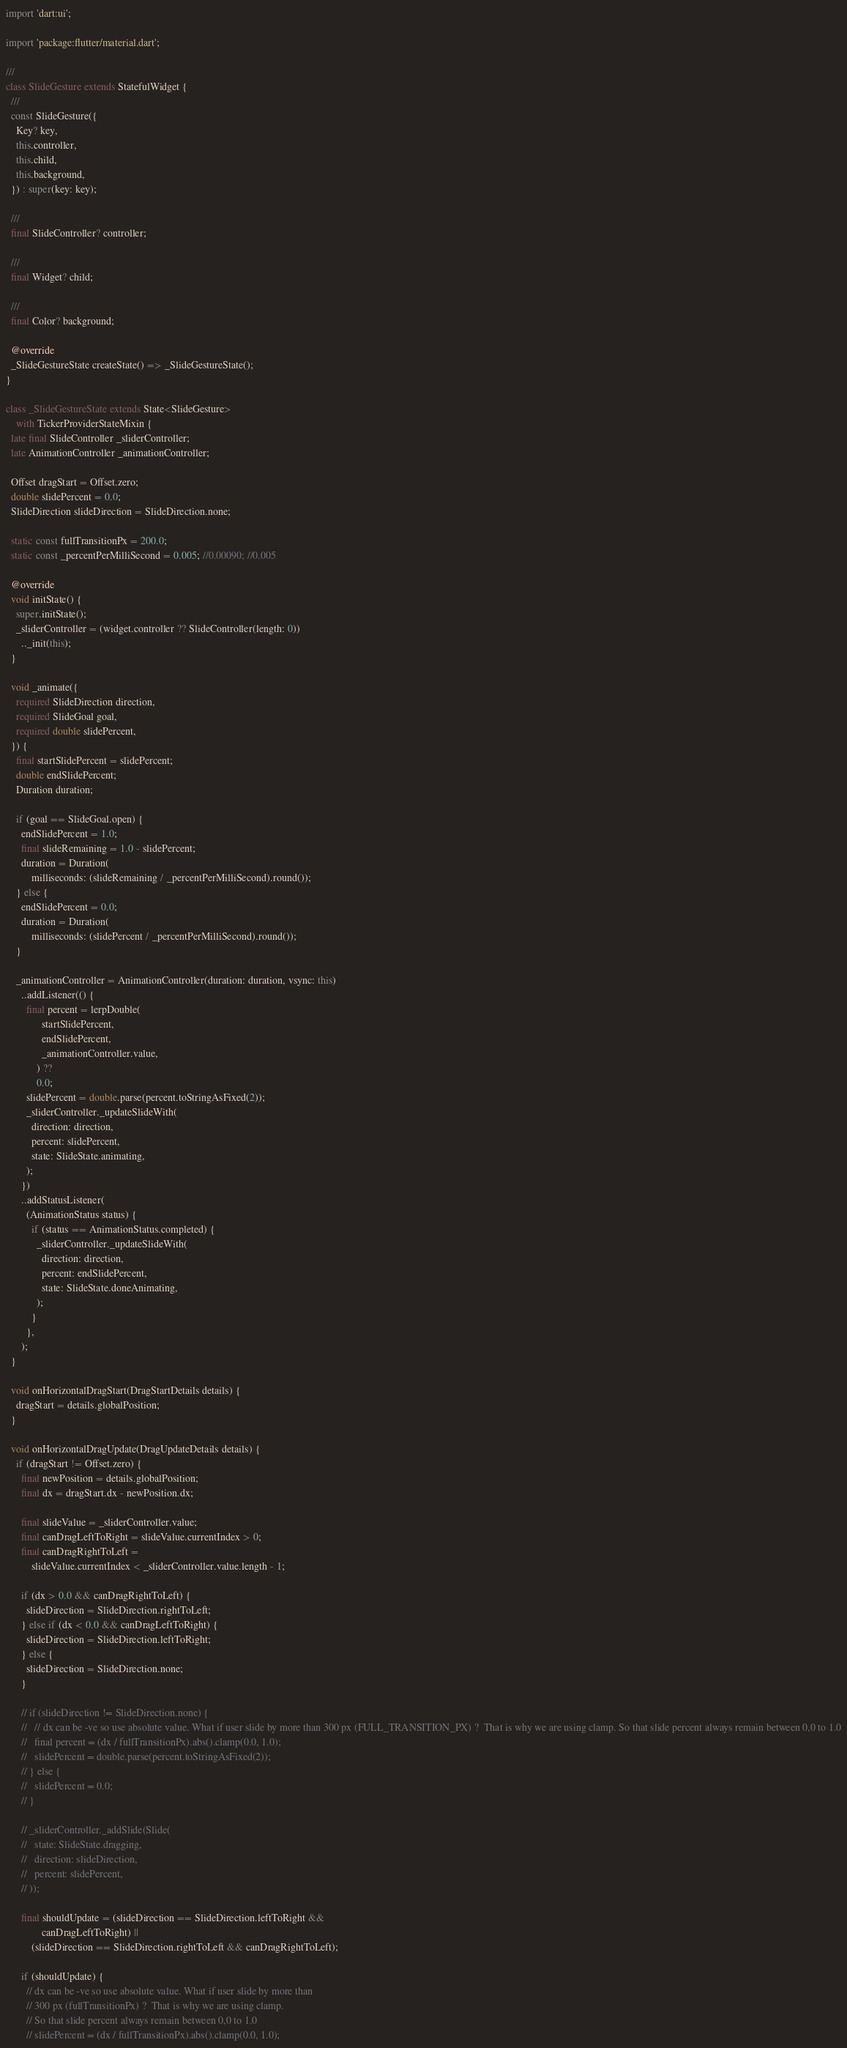Convert code to text. <code><loc_0><loc_0><loc_500><loc_500><_Dart_>import 'dart:ui';

import 'package:flutter/material.dart';

///
class SlideGesture extends StatefulWidget {
  ///
  const SlideGesture({
    Key? key,
    this.controller,
    this.child,
    this.background,
  }) : super(key: key);

  ///
  final SlideController? controller;

  ///
  final Widget? child;

  ///
  final Color? background;

  @override
  _SlideGestureState createState() => _SlideGestureState();
}

class _SlideGestureState extends State<SlideGesture>
    with TickerProviderStateMixin {
  late final SlideController _sliderController;
  late AnimationController _animationController;

  Offset dragStart = Offset.zero;
  double slidePercent = 0.0;
  SlideDirection slideDirection = SlideDirection.none;

  static const fullTransitionPx = 200.0;
  static const _percentPerMilliSecond = 0.005; //0.00090; //0.005

  @override
  void initState() {
    super.initState();
    _sliderController = (widget.controller ?? SlideController(length: 0))
      .._init(this);
  }

  void _animate({
    required SlideDirection direction,
    required SlideGoal goal,
    required double slidePercent,
  }) {
    final startSlidePercent = slidePercent;
    double endSlidePercent;
    Duration duration;

    if (goal == SlideGoal.open) {
      endSlidePercent = 1.0;
      final slideRemaining = 1.0 - slidePercent;
      duration = Duration(
          milliseconds: (slideRemaining / _percentPerMilliSecond).round());
    } else {
      endSlidePercent = 0.0;
      duration = Duration(
          milliseconds: (slidePercent / _percentPerMilliSecond).round());
    }

    _animationController = AnimationController(duration: duration, vsync: this)
      ..addListener(() {
        final percent = lerpDouble(
              startSlidePercent,
              endSlidePercent,
              _animationController.value,
            ) ??
            0.0;
        slidePercent = double.parse(percent.toStringAsFixed(2));
        _sliderController._updateSlideWith(
          direction: direction,
          percent: slidePercent,
          state: SlideState.animating,
        );
      })
      ..addStatusListener(
        (AnimationStatus status) {
          if (status == AnimationStatus.completed) {
            _sliderController._updateSlideWith(
              direction: direction,
              percent: endSlidePercent,
              state: SlideState.doneAnimating,
            );
          }
        },
      );
  }

  void onHorizontalDragStart(DragStartDetails details) {
    dragStart = details.globalPosition;
  }

  void onHorizontalDragUpdate(DragUpdateDetails details) {
    if (dragStart != Offset.zero) {
      final newPosition = details.globalPosition;
      final dx = dragStart.dx - newPosition.dx;

      final slideValue = _sliderController.value;
      final canDragLeftToRight = slideValue.currentIndex > 0;
      final canDragRightToLeft =
          slideValue.currentIndex < _sliderController.value.length - 1;

      if (dx > 0.0 && canDragRightToLeft) {
        slideDirection = SlideDirection.rightToLeft;
      } else if (dx < 0.0 && canDragLeftToRight) {
        slideDirection = SlideDirection.leftToRight;
      } else {
        slideDirection = SlideDirection.none;
      }

      // if (slideDirection != SlideDirection.none) {
      //   // dx can be -ve so use absolute value. What if user slide by more than 300 px (FULL_TRANSITION_PX) ?  That is why we are using clamp. So that slide percent always remain between 0,0 to 1.0
      //   final percent = (dx / fullTransitionPx).abs().clamp(0.0, 1.0);
      //   slidePercent = double.parse(percent.toStringAsFixed(2));
      // } else {
      //   slidePercent = 0.0;
      // }

      // _sliderController._addSlide(Slide(
      //   state: SlideState.dragging,
      //   direction: slideDirection,
      //   percent: slidePercent,
      // ));

      final shouldUpdate = (slideDirection == SlideDirection.leftToRight &&
              canDragLeftToRight) ||
          (slideDirection == SlideDirection.rightToLeft && canDragRightToLeft);

      if (shouldUpdate) {
        // dx can be -ve so use absolute value. What if user slide by more than
        // 300 px (fullTransitionPx) ?  That is why we are using clamp.
        // So that slide percent always remain between 0,0 to 1.0
        // slidePercent = (dx / fullTransitionPx).abs().clamp(0.0, 1.0);</code> 